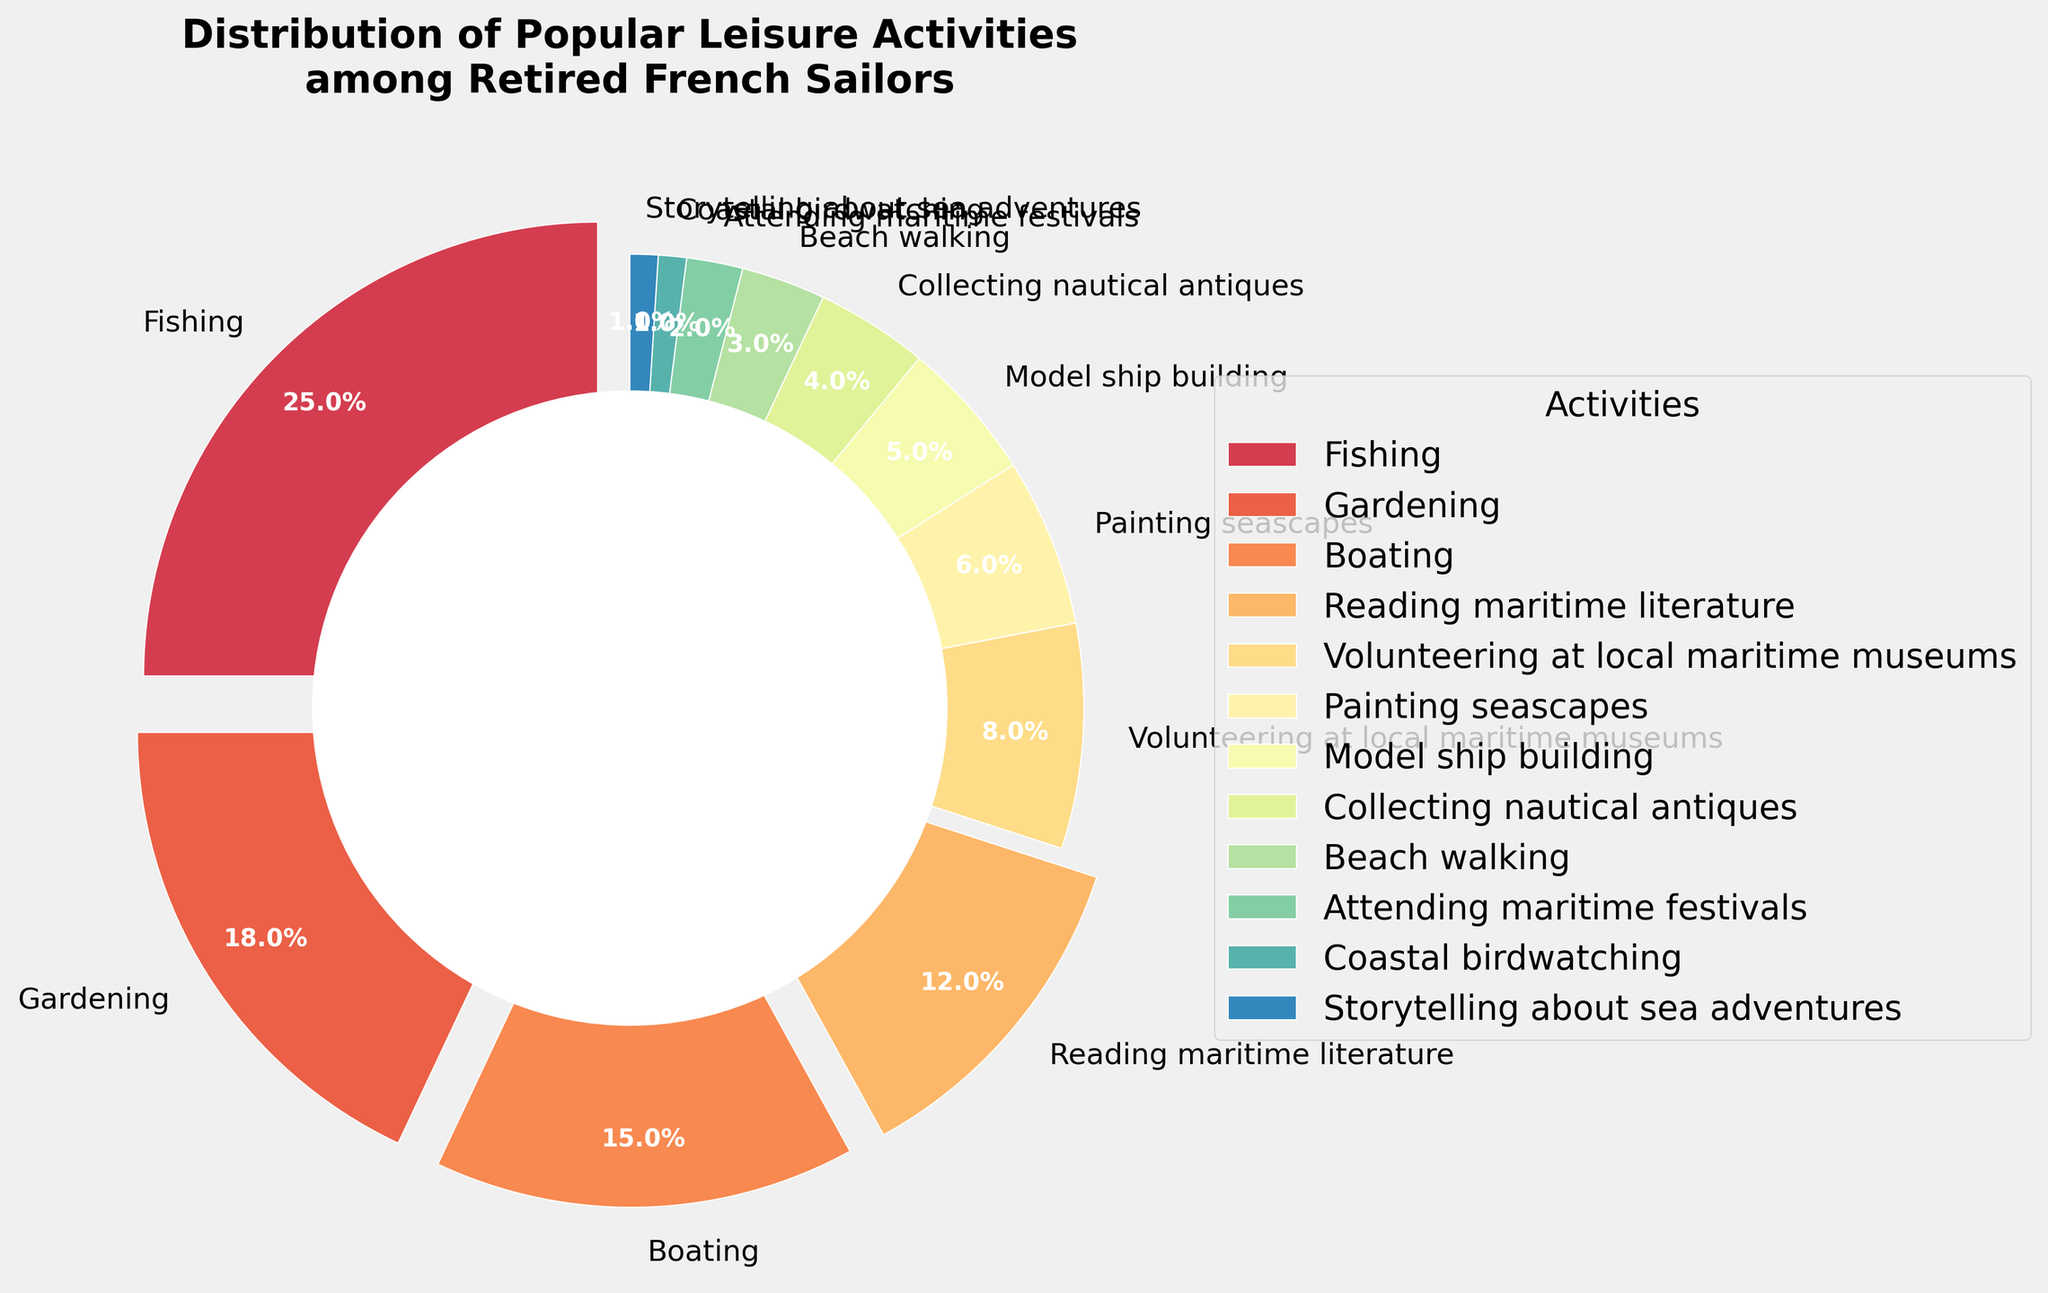what is the most popular leisure activity among retired French sailors? By looking at the figure, the largest wedge in the pie chart represents the most popular activity. The fishing activity has the largest share.
Answer: Fishing Which activities have a combined total percentage greater than boating? Take the percentage values of the activities and sum them up, comparing each sum against the percentage for boating (15%). For example, Fishing (25%) alone is already greater than Boating. Similarly, Gardening (18%) is also greater alone.
Answer: Fishing, Gardening What is the least popular leisure activity among retired French sailors? By identifying the smallest wedge in the pie chart, we can determine the least popular activity. The activity with 1% corresponding visually to the smallest wedge in the pie chart is Coastal birdwatching and Storytelling about sea adventures.
Answer: Coastal birdwatching and Storytelling about sea adventures What percentage of sailors prefer activities related to craft and art (including Painting seascapes, Model ship building, and Collecting nautical antiques)? Sum the percentages of the specified activities: Painting seascapes (6%), Model ship building (5%), and Collecting nautical antiques (4%). Adding them: 6% + 5% + 4% = 15%.
Answer: 15% How much more popular is fishing compared to beach walking? Subtract the percentage for Beach walking (3%) from the percentage for Fishing (25%). The difference is 25% - 3% = 22%.
Answer: 22% Which activities have similar percentages in the distribution? By observing the pie chart, we can identify that Model ship building (5%) and Collecting nautical antiques (4%) have close values visually.
Answer: Model ship building, Collecting nautical antiques If you combine the categories of Gardening and Reading maritime literature, what percentage of sailors engage in these combined activities? Sum the percentages for Gardening (18%) and Reading maritime literature (12%). The combined percentage is 18% + 12% = 30%.
Answer: 30% What percentage of sailors participate in activities directly related to the sea (include Fishing, Boating, Beach walking, and Coastal birdwatching)? Sum the percentages for the specified activities related to the sea: Fishing (25%), Boating (15%), Beach walking (3%), and Coastal birdwatching (1%). The total is 25% + 15% + 3% + 1% = 44%.
Answer: 44% 